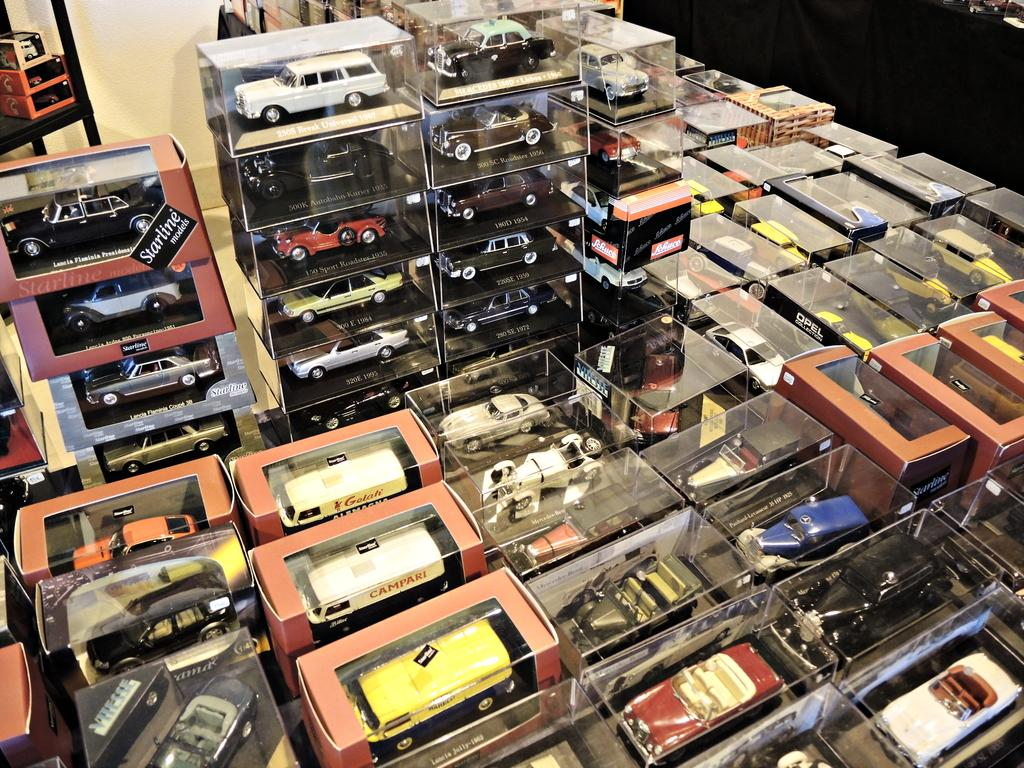What objects are present in the image? There are toys in the image. Where are the toys located? The toys are in cardboard boxes. Can you see a snail crawling on the toys in the image? No, there is no snail present in the image. 